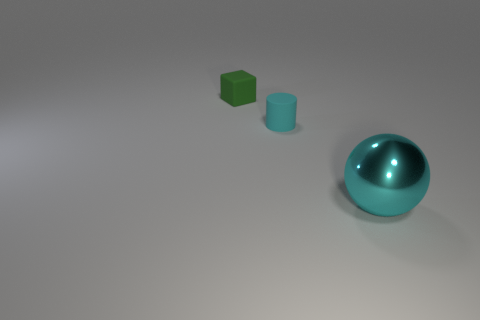Add 2 large cyan metallic things. How many objects exist? 5 Subtract 1 cylinders. How many cylinders are left? 0 Subtract 0 green cylinders. How many objects are left? 3 Subtract all spheres. How many objects are left? 2 Subtract all gray spheres. Subtract all blue cubes. How many spheres are left? 1 Subtract all cyan cylinders. Subtract all brown things. How many objects are left? 2 Add 3 small matte objects. How many small matte objects are left? 5 Add 2 small matte objects. How many small matte objects exist? 4 